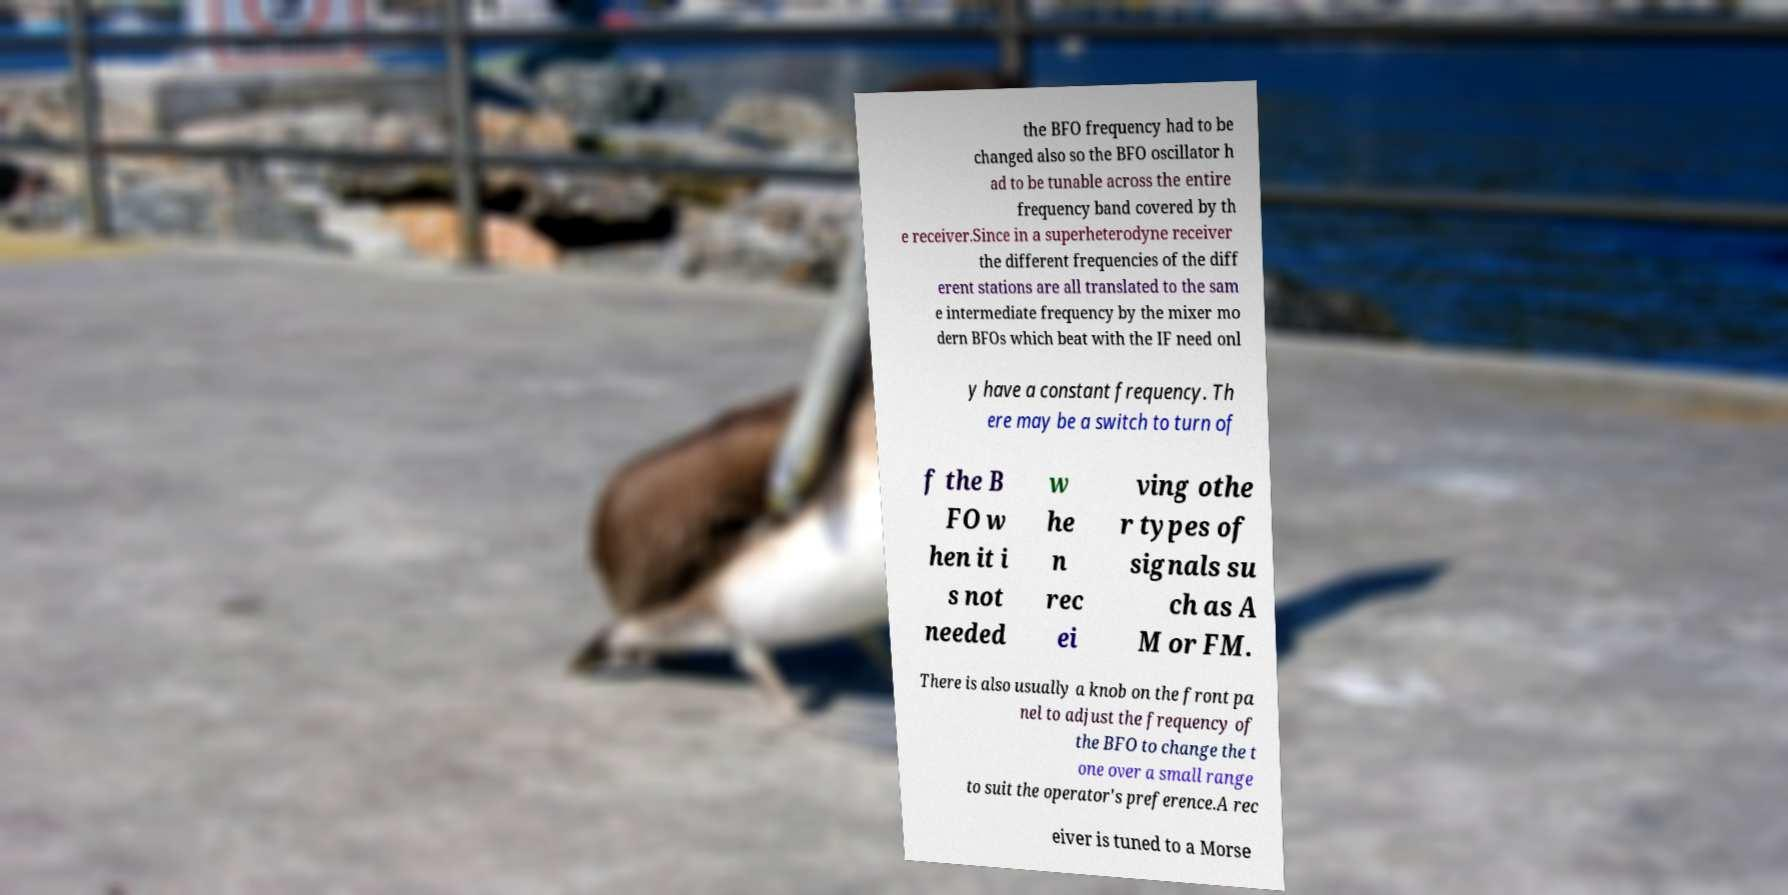Please identify and transcribe the text found in this image. the BFO frequency had to be changed also so the BFO oscillator h ad to be tunable across the entire frequency band covered by th e receiver.Since in a superheterodyne receiver the different frequencies of the diff erent stations are all translated to the sam e intermediate frequency by the mixer mo dern BFOs which beat with the IF need onl y have a constant frequency. Th ere may be a switch to turn of f the B FO w hen it i s not needed w he n rec ei ving othe r types of signals su ch as A M or FM. There is also usually a knob on the front pa nel to adjust the frequency of the BFO to change the t one over a small range to suit the operator's preference.A rec eiver is tuned to a Morse 